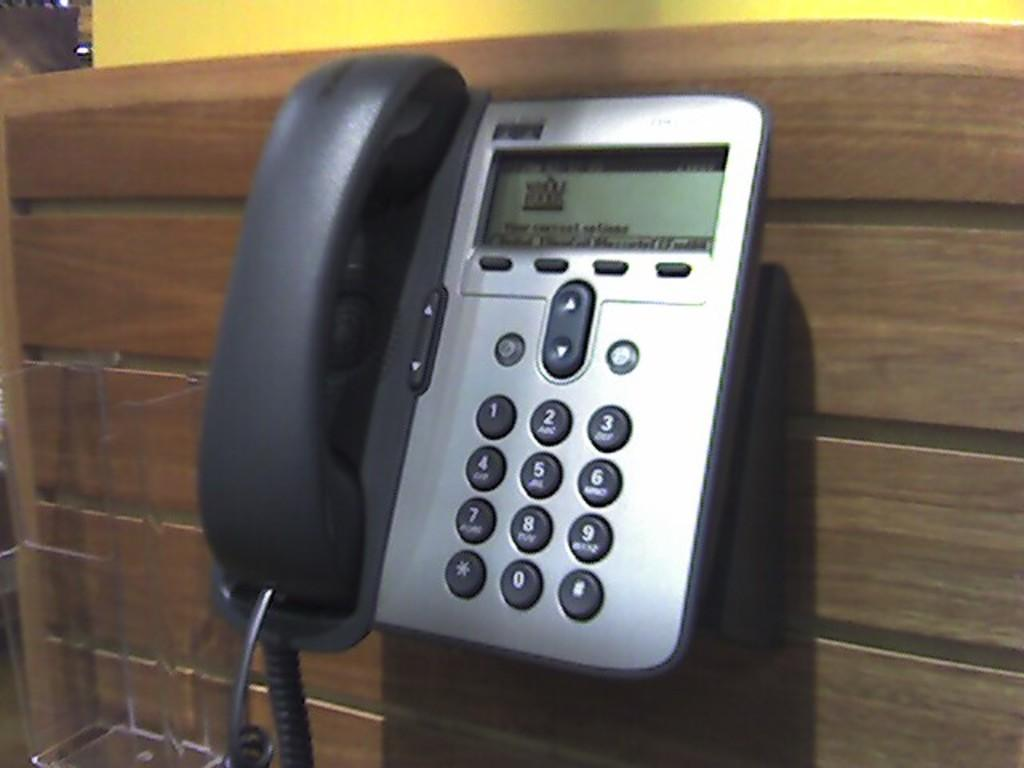What object is present in the image? There is a telephone in the image. What colors can be seen on the telephone? The telephone is black and silver in color. Where is the telephone located in the image? The telephone is hanging on a wooden wall. What type of collar is visible on the telephone in the image? There is no collar present on the telephone in the image. 